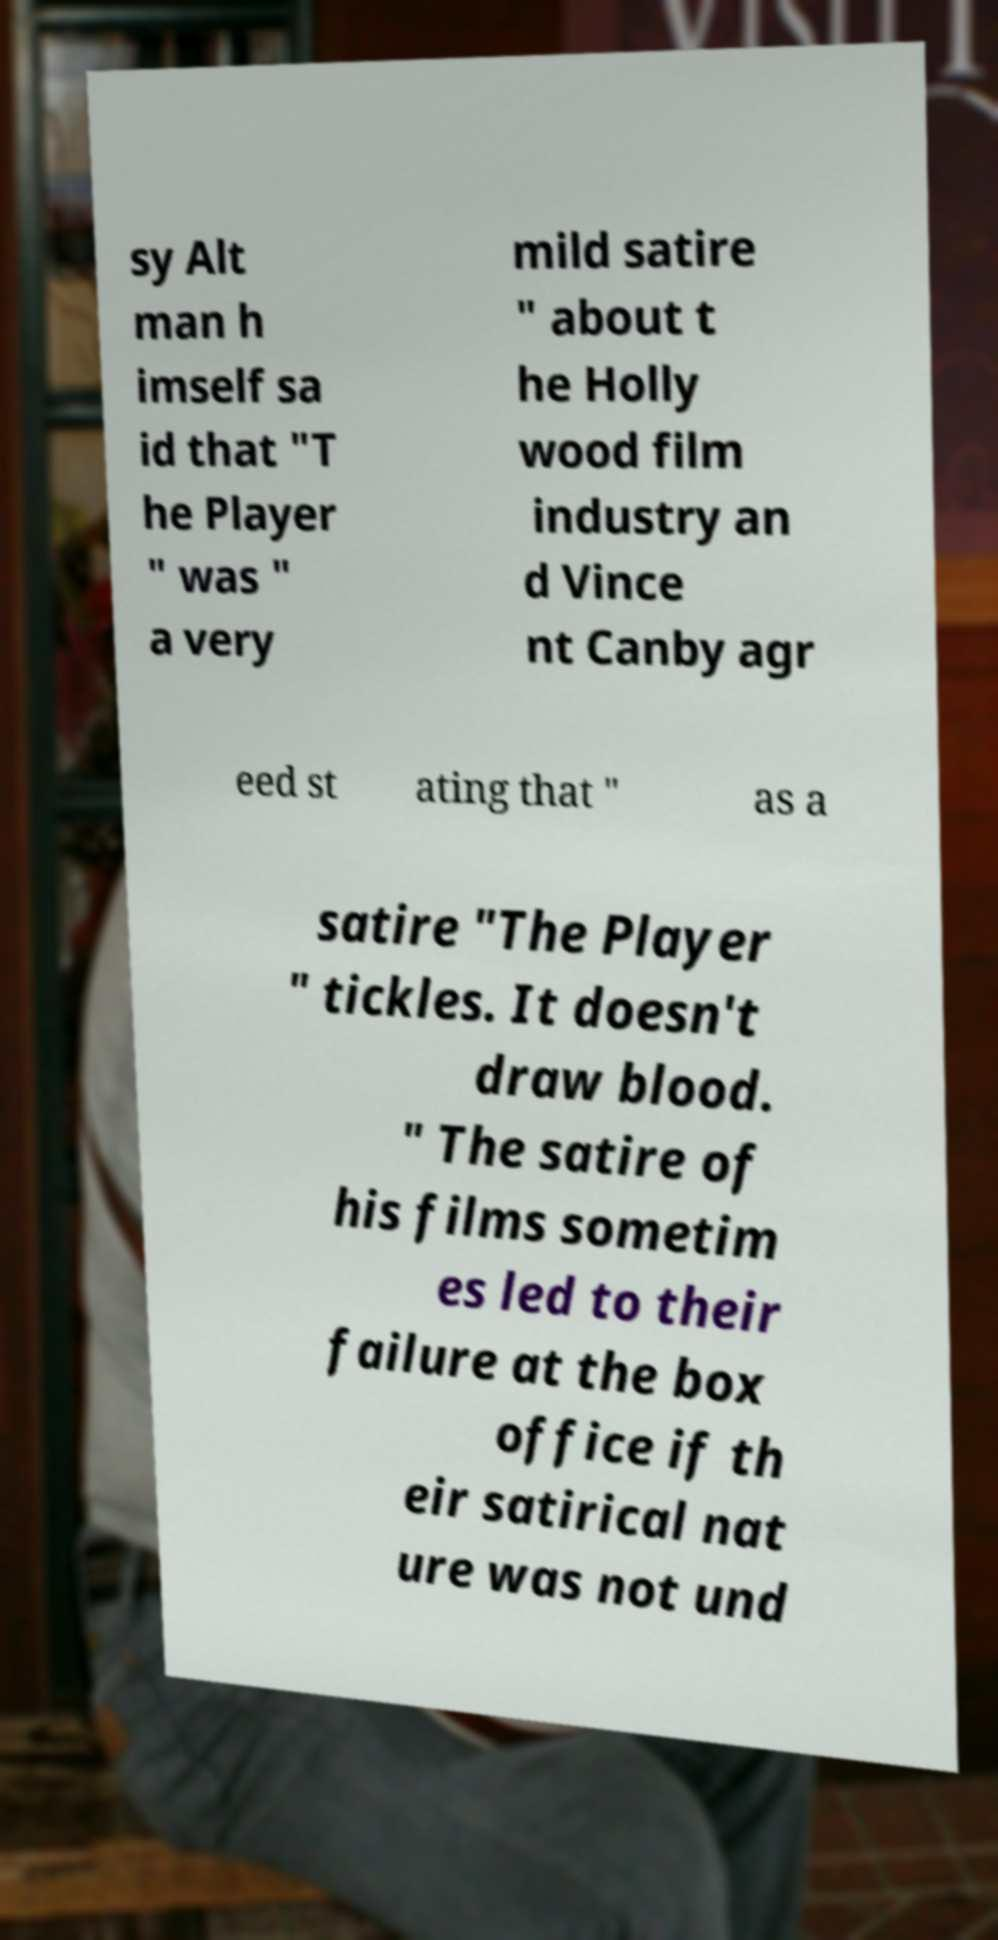I need the written content from this picture converted into text. Can you do that? sy Alt man h imself sa id that "T he Player " was " a very mild satire " about t he Holly wood film industry an d Vince nt Canby agr eed st ating that " as a satire "The Player " tickles. It doesn't draw blood. " The satire of his films sometim es led to their failure at the box office if th eir satirical nat ure was not und 